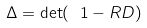Convert formula to latex. <formula><loc_0><loc_0><loc_500><loc_500>\Delta = \det ( \ 1 - R D )</formula> 